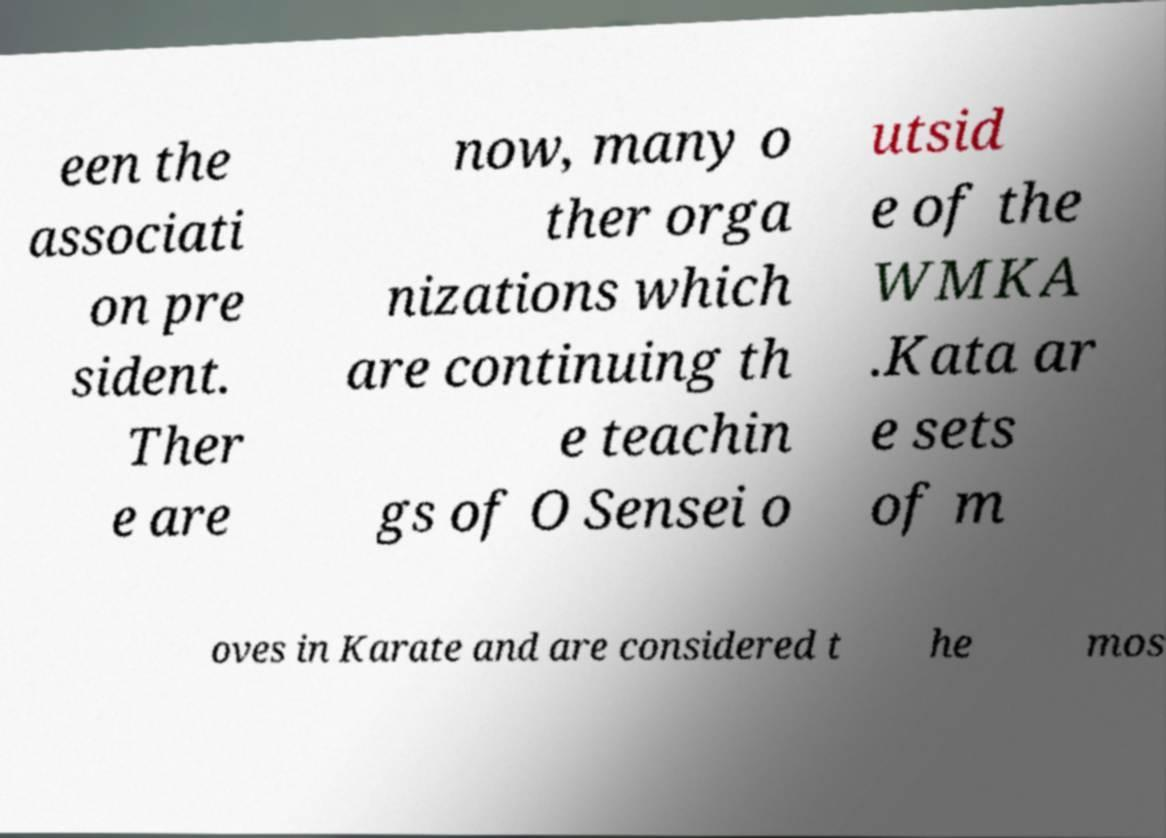Please read and relay the text visible in this image. What does it say? een the associati on pre sident. Ther e are now, many o ther orga nizations which are continuing th e teachin gs of O Sensei o utsid e of the WMKA .Kata ar e sets of m oves in Karate and are considered t he mos 